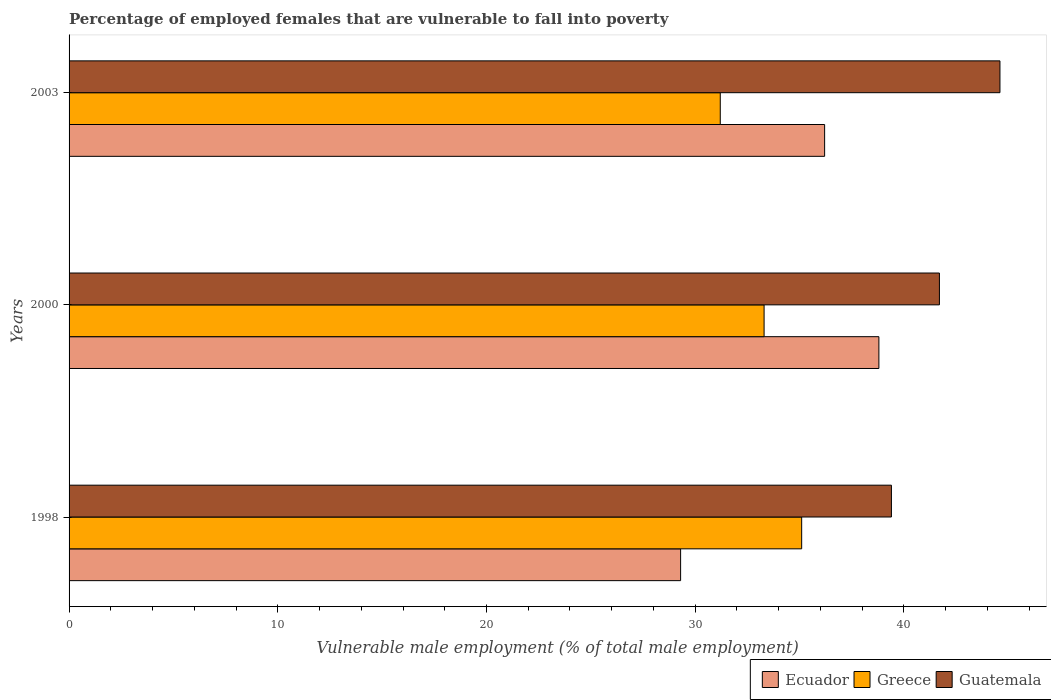How many groups of bars are there?
Provide a short and direct response. 3. How many bars are there on the 2nd tick from the top?
Provide a succinct answer. 3. What is the label of the 1st group of bars from the top?
Offer a very short reply. 2003. In how many cases, is the number of bars for a given year not equal to the number of legend labels?
Keep it short and to the point. 0. What is the percentage of employed females who are vulnerable to fall into poverty in Greece in 2000?
Offer a terse response. 33.3. Across all years, what is the maximum percentage of employed females who are vulnerable to fall into poverty in Ecuador?
Provide a succinct answer. 38.8. Across all years, what is the minimum percentage of employed females who are vulnerable to fall into poverty in Ecuador?
Provide a succinct answer. 29.3. In which year was the percentage of employed females who are vulnerable to fall into poverty in Guatemala maximum?
Provide a succinct answer. 2003. In which year was the percentage of employed females who are vulnerable to fall into poverty in Guatemala minimum?
Ensure brevity in your answer.  1998. What is the total percentage of employed females who are vulnerable to fall into poverty in Ecuador in the graph?
Ensure brevity in your answer.  104.3. What is the difference between the percentage of employed females who are vulnerable to fall into poverty in Ecuador in 2000 and that in 2003?
Give a very brief answer. 2.6. What is the difference between the percentage of employed females who are vulnerable to fall into poverty in Greece in 2000 and the percentage of employed females who are vulnerable to fall into poverty in Ecuador in 1998?
Offer a very short reply. 4. What is the average percentage of employed females who are vulnerable to fall into poverty in Guatemala per year?
Provide a succinct answer. 41.9. In the year 2000, what is the difference between the percentage of employed females who are vulnerable to fall into poverty in Ecuador and percentage of employed females who are vulnerable to fall into poverty in Guatemala?
Offer a terse response. -2.9. What is the ratio of the percentage of employed females who are vulnerable to fall into poverty in Greece in 2000 to that in 2003?
Make the answer very short. 1.07. Is the percentage of employed females who are vulnerable to fall into poverty in Guatemala in 1998 less than that in 2000?
Your response must be concise. Yes. Is the difference between the percentage of employed females who are vulnerable to fall into poverty in Ecuador in 1998 and 2003 greater than the difference between the percentage of employed females who are vulnerable to fall into poverty in Guatemala in 1998 and 2003?
Give a very brief answer. No. What is the difference between the highest and the second highest percentage of employed females who are vulnerable to fall into poverty in Greece?
Provide a short and direct response. 1.8. What is the difference between the highest and the lowest percentage of employed females who are vulnerable to fall into poverty in Guatemala?
Your response must be concise. 5.2. In how many years, is the percentage of employed females who are vulnerable to fall into poverty in Guatemala greater than the average percentage of employed females who are vulnerable to fall into poverty in Guatemala taken over all years?
Your response must be concise. 1. What does the 1st bar from the top in 2000 represents?
Give a very brief answer. Guatemala. What does the 1st bar from the bottom in 2000 represents?
Provide a succinct answer. Ecuador. How many bars are there?
Provide a succinct answer. 9. Are all the bars in the graph horizontal?
Offer a very short reply. Yes. How many legend labels are there?
Provide a succinct answer. 3. What is the title of the graph?
Offer a very short reply. Percentage of employed females that are vulnerable to fall into poverty. Does "Comoros" appear as one of the legend labels in the graph?
Your answer should be compact. No. What is the label or title of the X-axis?
Your answer should be compact. Vulnerable male employment (% of total male employment). What is the Vulnerable male employment (% of total male employment) in Ecuador in 1998?
Offer a terse response. 29.3. What is the Vulnerable male employment (% of total male employment) of Greece in 1998?
Your answer should be compact. 35.1. What is the Vulnerable male employment (% of total male employment) in Guatemala in 1998?
Provide a succinct answer. 39.4. What is the Vulnerable male employment (% of total male employment) of Ecuador in 2000?
Your answer should be very brief. 38.8. What is the Vulnerable male employment (% of total male employment) of Greece in 2000?
Your answer should be very brief. 33.3. What is the Vulnerable male employment (% of total male employment) of Guatemala in 2000?
Keep it short and to the point. 41.7. What is the Vulnerable male employment (% of total male employment) in Ecuador in 2003?
Offer a terse response. 36.2. What is the Vulnerable male employment (% of total male employment) of Greece in 2003?
Keep it short and to the point. 31.2. What is the Vulnerable male employment (% of total male employment) in Guatemala in 2003?
Provide a short and direct response. 44.6. Across all years, what is the maximum Vulnerable male employment (% of total male employment) of Ecuador?
Provide a short and direct response. 38.8. Across all years, what is the maximum Vulnerable male employment (% of total male employment) of Greece?
Your answer should be very brief. 35.1. Across all years, what is the maximum Vulnerable male employment (% of total male employment) of Guatemala?
Offer a terse response. 44.6. Across all years, what is the minimum Vulnerable male employment (% of total male employment) of Ecuador?
Make the answer very short. 29.3. Across all years, what is the minimum Vulnerable male employment (% of total male employment) in Greece?
Your response must be concise. 31.2. Across all years, what is the minimum Vulnerable male employment (% of total male employment) of Guatemala?
Provide a short and direct response. 39.4. What is the total Vulnerable male employment (% of total male employment) in Ecuador in the graph?
Your response must be concise. 104.3. What is the total Vulnerable male employment (% of total male employment) in Greece in the graph?
Offer a terse response. 99.6. What is the total Vulnerable male employment (% of total male employment) of Guatemala in the graph?
Make the answer very short. 125.7. What is the difference between the Vulnerable male employment (% of total male employment) in Greece in 1998 and that in 2000?
Keep it short and to the point. 1.8. What is the difference between the Vulnerable male employment (% of total male employment) in Guatemala in 1998 and that in 2000?
Make the answer very short. -2.3. What is the difference between the Vulnerable male employment (% of total male employment) of Ecuador in 1998 and that in 2003?
Keep it short and to the point. -6.9. What is the difference between the Vulnerable male employment (% of total male employment) of Guatemala in 1998 and that in 2003?
Your answer should be very brief. -5.2. What is the difference between the Vulnerable male employment (% of total male employment) in Ecuador in 2000 and that in 2003?
Your answer should be very brief. 2.6. What is the difference between the Vulnerable male employment (% of total male employment) of Guatemala in 2000 and that in 2003?
Your answer should be compact. -2.9. What is the difference between the Vulnerable male employment (% of total male employment) of Ecuador in 1998 and the Vulnerable male employment (% of total male employment) of Guatemala in 2000?
Offer a terse response. -12.4. What is the difference between the Vulnerable male employment (% of total male employment) of Greece in 1998 and the Vulnerable male employment (% of total male employment) of Guatemala in 2000?
Offer a terse response. -6.6. What is the difference between the Vulnerable male employment (% of total male employment) of Ecuador in 1998 and the Vulnerable male employment (% of total male employment) of Guatemala in 2003?
Provide a short and direct response. -15.3. What is the difference between the Vulnerable male employment (% of total male employment) of Greece in 1998 and the Vulnerable male employment (% of total male employment) of Guatemala in 2003?
Keep it short and to the point. -9.5. What is the difference between the Vulnerable male employment (% of total male employment) of Ecuador in 2000 and the Vulnerable male employment (% of total male employment) of Greece in 2003?
Make the answer very short. 7.6. What is the difference between the Vulnerable male employment (% of total male employment) in Ecuador in 2000 and the Vulnerable male employment (% of total male employment) in Guatemala in 2003?
Make the answer very short. -5.8. What is the difference between the Vulnerable male employment (% of total male employment) in Greece in 2000 and the Vulnerable male employment (% of total male employment) in Guatemala in 2003?
Make the answer very short. -11.3. What is the average Vulnerable male employment (% of total male employment) in Ecuador per year?
Ensure brevity in your answer.  34.77. What is the average Vulnerable male employment (% of total male employment) in Greece per year?
Offer a terse response. 33.2. What is the average Vulnerable male employment (% of total male employment) in Guatemala per year?
Give a very brief answer. 41.9. In the year 1998, what is the difference between the Vulnerable male employment (% of total male employment) of Ecuador and Vulnerable male employment (% of total male employment) of Greece?
Your answer should be very brief. -5.8. In the year 1998, what is the difference between the Vulnerable male employment (% of total male employment) of Ecuador and Vulnerable male employment (% of total male employment) of Guatemala?
Give a very brief answer. -10.1. In the year 2000, what is the difference between the Vulnerable male employment (% of total male employment) of Ecuador and Vulnerable male employment (% of total male employment) of Guatemala?
Provide a short and direct response. -2.9. In the year 2003, what is the difference between the Vulnerable male employment (% of total male employment) in Ecuador and Vulnerable male employment (% of total male employment) in Greece?
Offer a terse response. 5. In the year 2003, what is the difference between the Vulnerable male employment (% of total male employment) of Ecuador and Vulnerable male employment (% of total male employment) of Guatemala?
Provide a short and direct response. -8.4. In the year 2003, what is the difference between the Vulnerable male employment (% of total male employment) in Greece and Vulnerable male employment (% of total male employment) in Guatemala?
Offer a terse response. -13.4. What is the ratio of the Vulnerable male employment (% of total male employment) in Ecuador in 1998 to that in 2000?
Your answer should be compact. 0.76. What is the ratio of the Vulnerable male employment (% of total male employment) of Greece in 1998 to that in 2000?
Provide a succinct answer. 1.05. What is the ratio of the Vulnerable male employment (% of total male employment) in Guatemala in 1998 to that in 2000?
Give a very brief answer. 0.94. What is the ratio of the Vulnerable male employment (% of total male employment) in Ecuador in 1998 to that in 2003?
Make the answer very short. 0.81. What is the ratio of the Vulnerable male employment (% of total male employment) in Guatemala in 1998 to that in 2003?
Provide a short and direct response. 0.88. What is the ratio of the Vulnerable male employment (% of total male employment) in Ecuador in 2000 to that in 2003?
Keep it short and to the point. 1.07. What is the ratio of the Vulnerable male employment (% of total male employment) in Greece in 2000 to that in 2003?
Make the answer very short. 1.07. What is the ratio of the Vulnerable male employment (% of total male employment) in Guatemala in 2000 to that in 2003?
Make the answer very short. 0.94. What is the difference between the highest and the second highest Vulnerable male employment (% of total male employment) in Ecuador?
Ensure brevity in your answer.  2.6. What is the difference between the highest and the lowest Vulnerable male employment (% of total male employment) in Guatemala?
Make the answer very short. 5.2. 